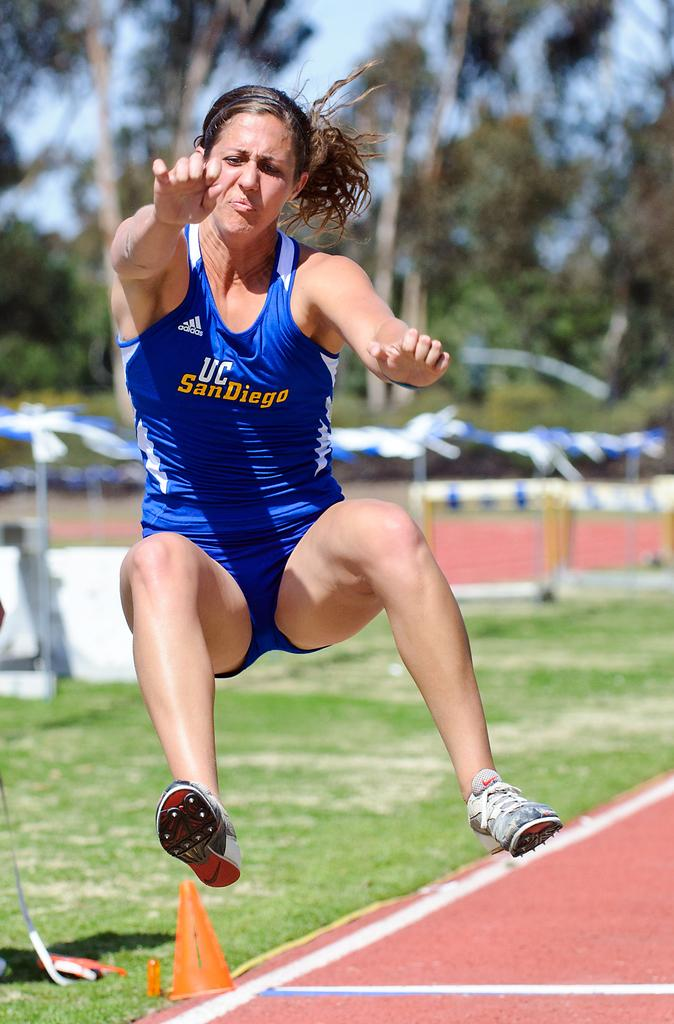What is the main subject of the image? There is a woman in the air in the image. How would you describe the background of the image? The background of the image is blurry. Can you identify any specific objects in the image? Yes, there is a traffic cone in the image. What type of natural environment is visible in the image? Grass, trees, and the sky are visible in the image. How many subjects can be seen in the image? There is one main subject, the woman in the air, and at least one object, the traffic cone. Can you see any ants crawling on the twig in the image? There is no twig or ants present in the image. What type of thunder can be heard in the image? There is no thunder present in the image, as it is a visual medium and does not include sound. 